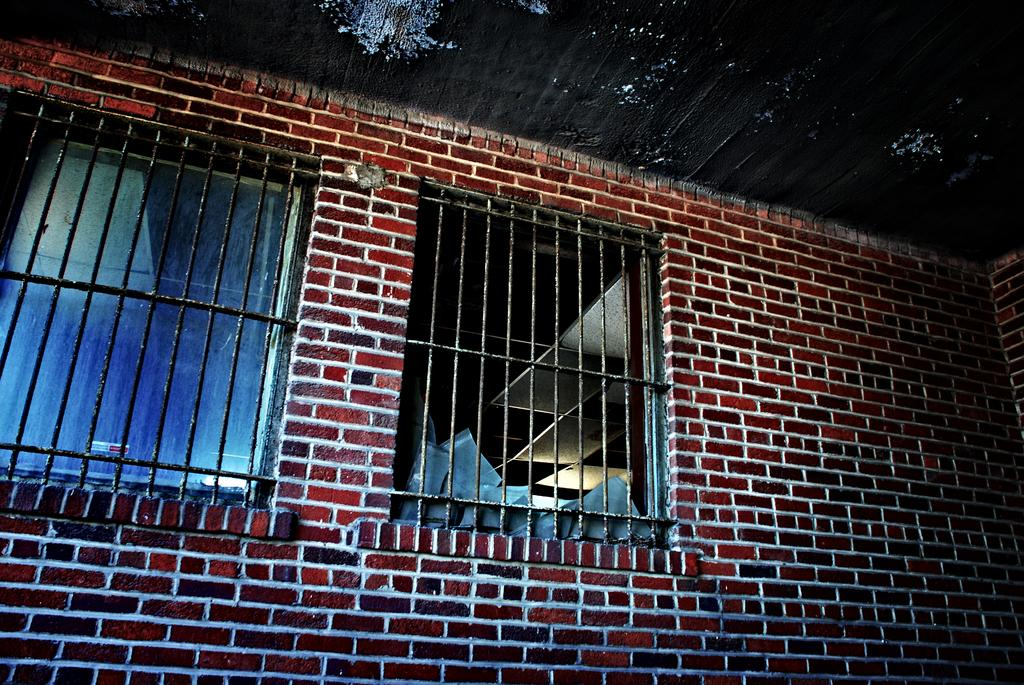What type of structure is visible in the image? There is a brick wall in the image. What feature is present in the brick wall? There are windows in the brick wall. What can be seen through the windows? The windows allow a view of view of the ceiling and objects visible through the windows. What color is the pencil that is being used to draw on the ceiling? There is no pencil present in the image, and therefore no drawing on the ceiling. 